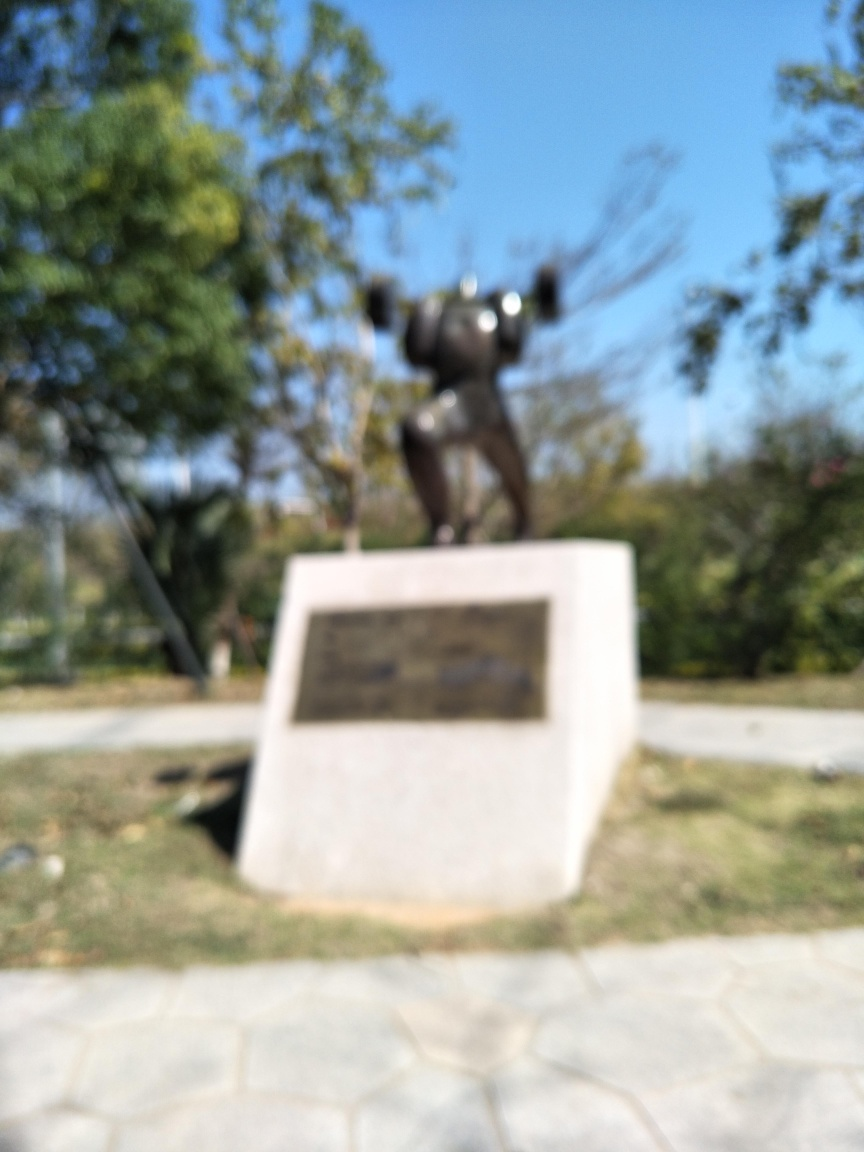Can you describe what is in the center of this photo despite its blurriness? Although details are obscured due to the blurriness, the central object of the photo appears to be a statue. The figure seems to have outstretched arms and stands on a pedestal or platform, which suggests that it is a statue meant for public display. What can you infer about the surroundings of the statue? From the environment visible in the blurry image, it seems like the statue is situated outdoors. There are trees in the background that indicate a park or a similar open space. The ground has a paved, stone-like texture, commonly found in outdoor public spaces designed for foot traffic. 